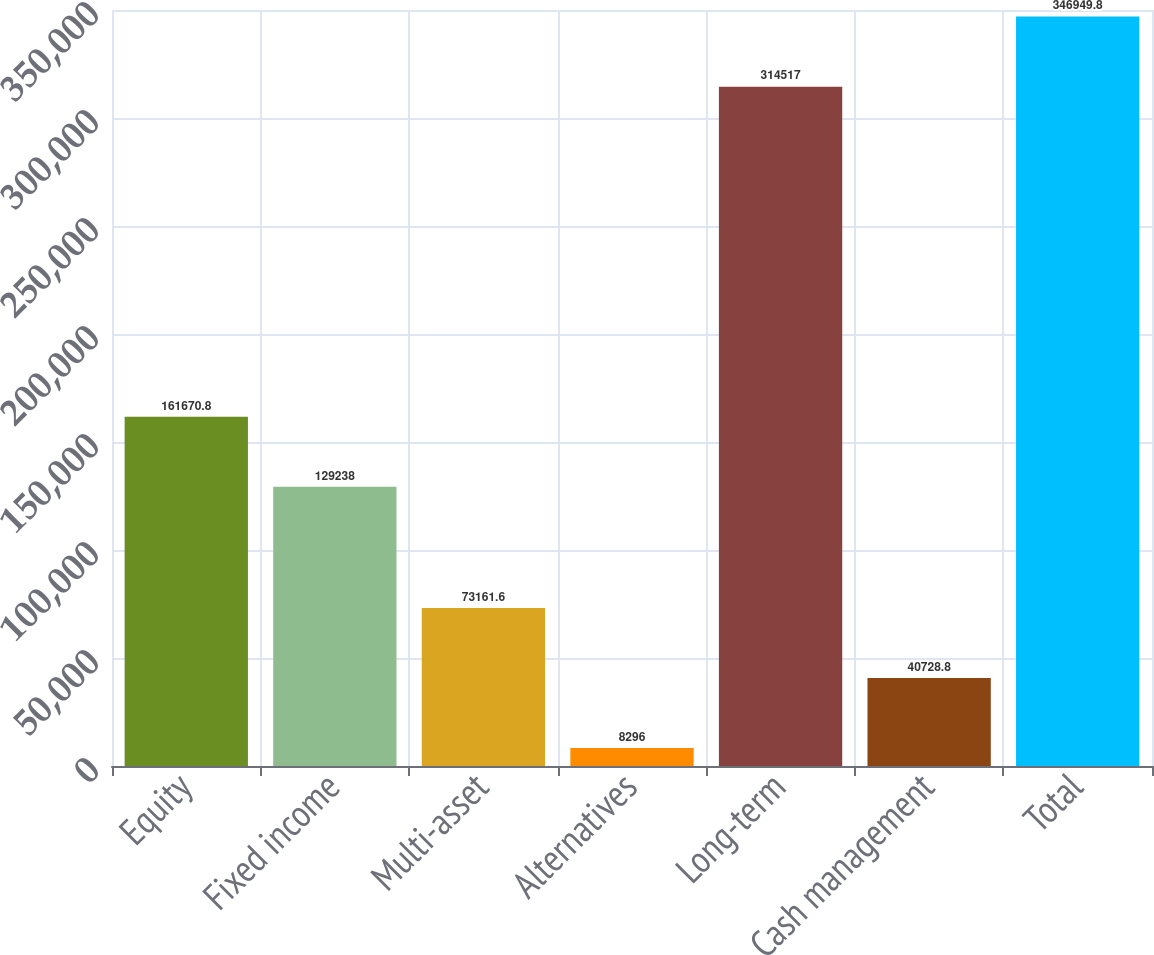Convert chart to OTSL. <chart><loc_0><loc_0><loc_500><loc_500><bar_chart><fcel>Equity<fcel>Fixed income<fcel>Multi-asset<fcel>Alternatives<fcel>Long-term<fcel>Cash management<fcel>Total<nl><fcel>161671<fcel>129238<fcel>73161.6<fcel>8296<fcel>314517<fcel>40728.8<fcel>346950<nl></chart> 